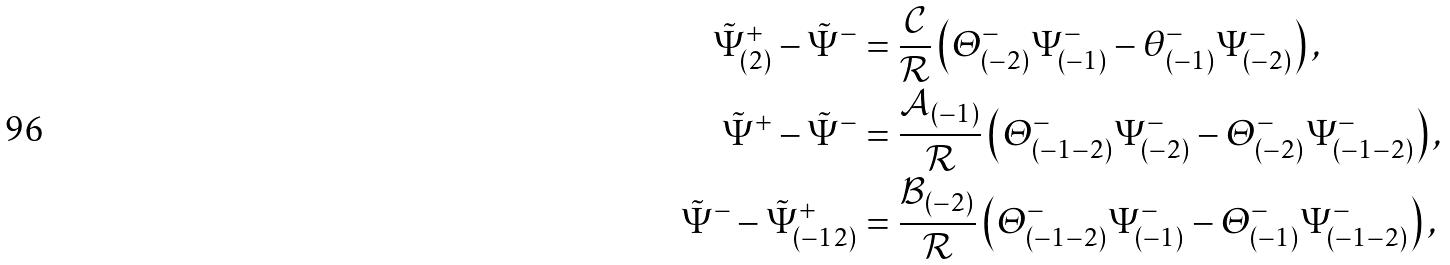Convert formula to latex. <formula><loc_0><loc_0><loc_500><loc_500>\tilde { \Psi } ^ { + } _ { ( 2 ) } - \tilde { \Psi } ^ { - } & = \frac { \mathcal { C } } { \mathcal { R } } \left ( \varTheta ^ { - } _ { ( - 2 ) } \Psi ^ { - } _ { ( - 1 ) } - \theta ^ { - } _ { ( - 1 ) } \Psi ^ { - } _ { ( - 2 ) } \right ) , \\ \tilde { \Psi } ^ { + } - \tilde { \Psi } ^ { - } & = \frac { { \mathcal { A } } _ { ( - 1 ) } } { \mathcal { R } } \left ( \varTheta ^ { - } _ { ( - 1 - 2 ) } \Psi ^ { - } _ { ( - 2 ) } - \varTheta ^ { - } _ { ( - 2 ) } \Psi ^ { - } _ { ( - 1 - 2 ) } \right ) , \\ \tilde { \Psi } ^ { - } - \tilde { \Psi } ^ { + } _ { ( - 1 2 ) } & = \frac { { \mathcal { B } } _ { ( - 2 ) } } { \mathcal { R } } \left ( \varTheta ^ { - } _ { ( - 1 - 2 ) } \Psi ^ { - } _ { ( - 1 ) } - \varTheta ^ { - } _ { ( - 1 ) } \Psi ^ { - } _ { ( - 1 - 2 ) } \right ) ,</formula> 